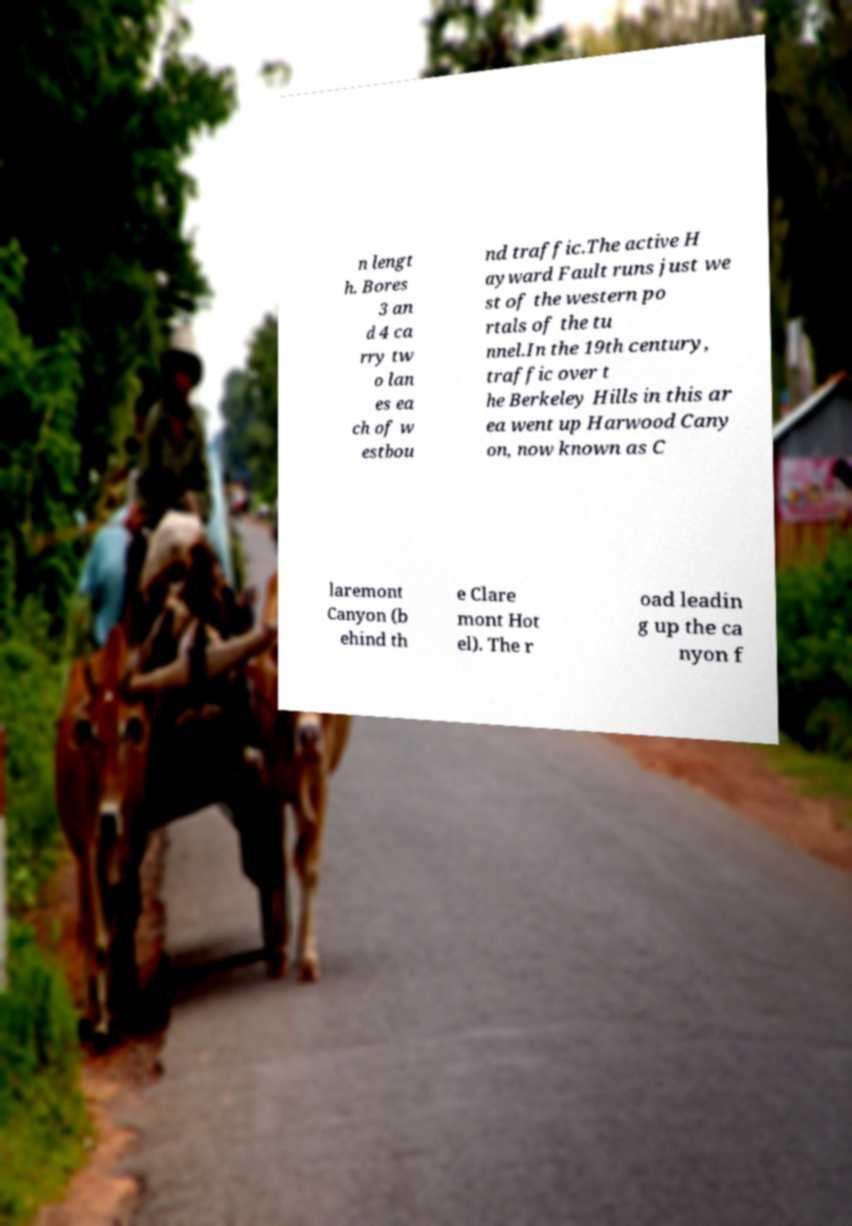Please read and relay the text visible in this image. What does it say? n lengt h. Bores 3 an d 4 ca rry tw o lan es ea ch of w estbou nd traffic.The active H ayward Fault runs just we st of the western po rtals of the tu nnel.In the 19th century, traffic over t he Berkeley Hills in this ar ea went up Harwood Cany on, now known as C laremont Canyon (b ehind th e Clare mont Hot el). The r oad leadin g up the ca nyon f 